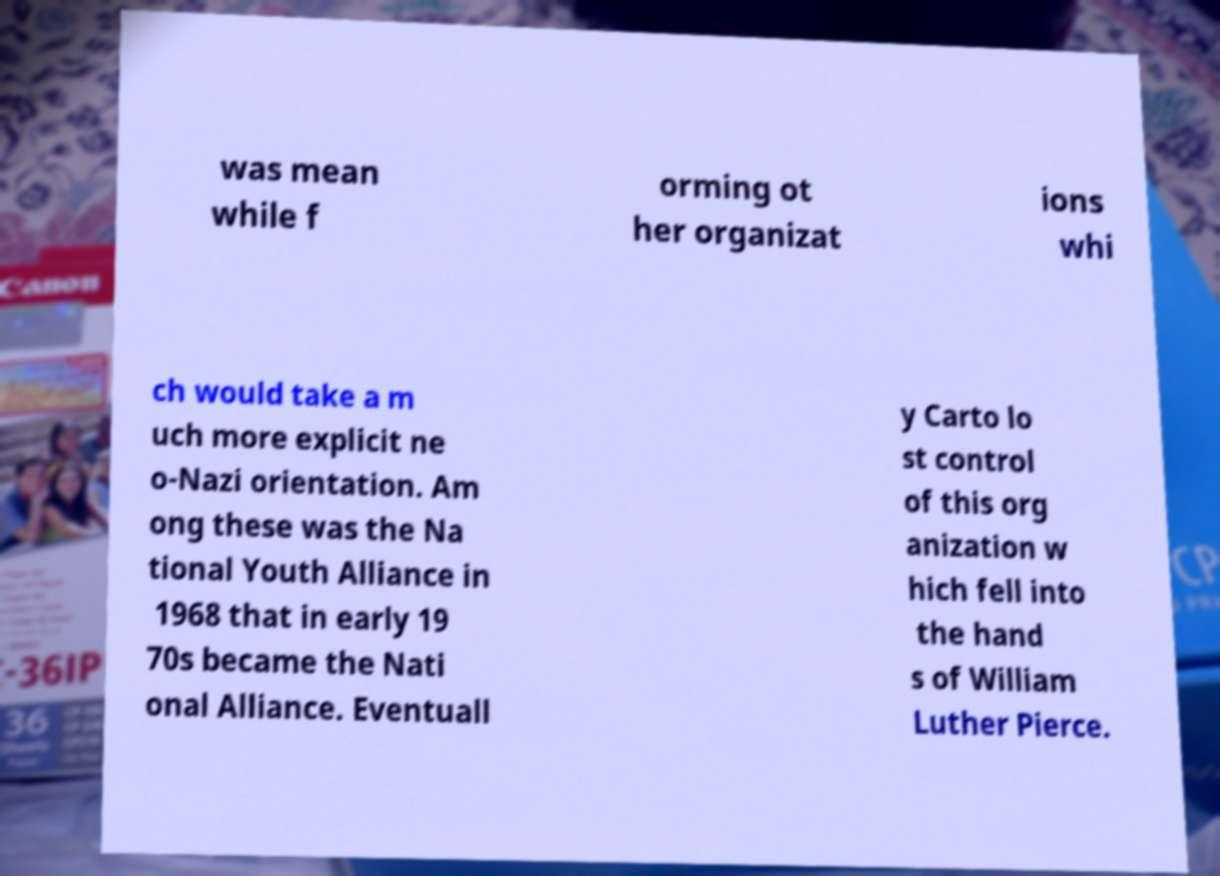Could you assist in decoding the text presented in this image and type it out clearly? was mean while f orming ot her organizat ions whi ch would take a m uch more explicit ne o-Nazi orientation. Am ong these was the Na tional Youth Alliance in 1968 that in early 19 70s became the Nati onal Alliance. Eventuall y Carto lo st control of this org anization w hich fell into the hand s of William Luther Pierce. 